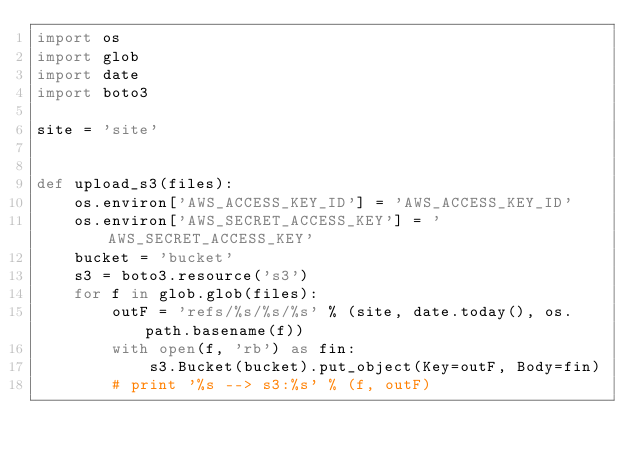<code> <loc_0><loc_0><loc_500><loc_500><_Python_>import os
import glob
import date
import boto3

site = 'site'


def upload_s3(files):
    os.environ['AWS_ACCESS_KEY_ID'] = 'AWS_ACCESS_KEY_ID'
    os.environ['AWS_SECRET_ACCESS_KEY'] = 'AWS_SECRET_ACCESS_KEY'
    bucket = 'bucket'
    s3 = boto3.resource('s3')
    for f in glob.glob(files):
        outF = 'refs/%s/%s/%s' % (site, date.today(), os.path.basename(f))
        with open(f, 'rb') as fin:
            s3.Bucket(bucket).put_object(Key=outF, Body=fin)
        # print '%s --> s3:%s' % (f, outF)
</code> 